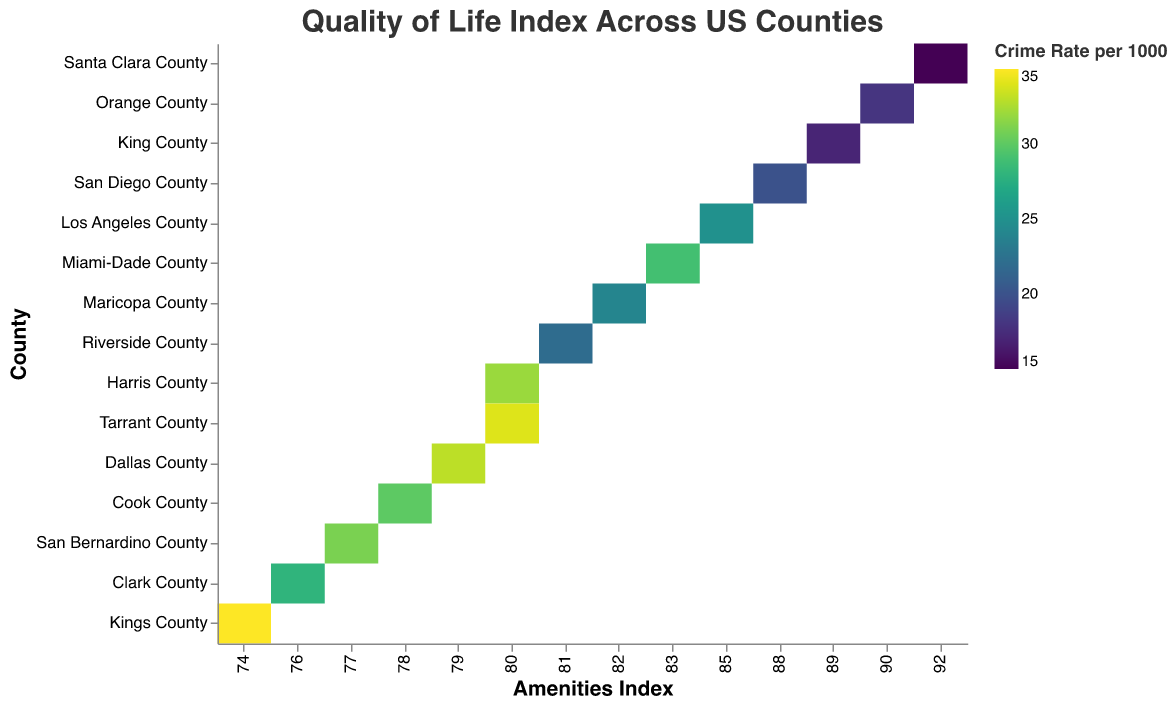What is the title of the heatmap? The title of the heatmap is located at the top of the figure and it reads "Quality of Life Index Across US Counties".
Answer: Quality of Life Index Across US Counties Which county has the highest Amenities Index? By examining the x-axis where the Amenities Index is represented, Santa Clara County has the highest value of 92.
Answer: Santa Clara County What is the range of the Air Quality Index values in the heatmap? The Air Quality Index values range between 61 and 80, as indicated by the size of the cells, with Santa Clara County having the highest Air Quality Index of 80, and Kings County the lowest at 61.
Answer: 61 to 80 Which county has the lowest crime rate? The color of the cells represents the crime rate, with lighter colors indicating lower rates. King County has the lightest cell color, showing a crime rate per 1000 of 17.
Answer: King County What is the average Green Space Percentage across all counties? The Green Space Percentage values are 18, 15, 20, 25, 22, 24, 17, 21, 12, 19, 23, 20, 26, 22, and 27. Summing these up gives 311, and dividing by the number of counties (15) gives an average of 20.73%.
Answer: 20.73% Compare the crime rates of Cook County and Tarrant County. Which has a higher rate? Cook County has a crime rate of 30 per 1000, and Tarrant County has a crime rate of 34 per 1000. Tarrant County has the higher crime rate.
Answer: Tarrant County Which counties have an Air Quality Index greater than 75? Counties with an Air Quality Index greater than 75 are those with larger cell sizes. These counties are Orange County (78), King County (79), and Santa Clara County (80).
Answer: Orange County, King County, Santa Clara County What is the Amenities Index of Maricopa County and how does it compare to the index of San Diego County? Maricopa County has an Amenities Index of 82, while San Diego County has an index of 88. Maricopa County's Amenities Index is 6 points lower than San Diego County's.
Answer: Maricopa County: 82, 6 points lower Identify the county with the highest Green Space Percentage. By looking at the tooltip and comparing Green Space Percentages, Santa Clara County has the highest at 27%.
Answer: Santa Clara County 